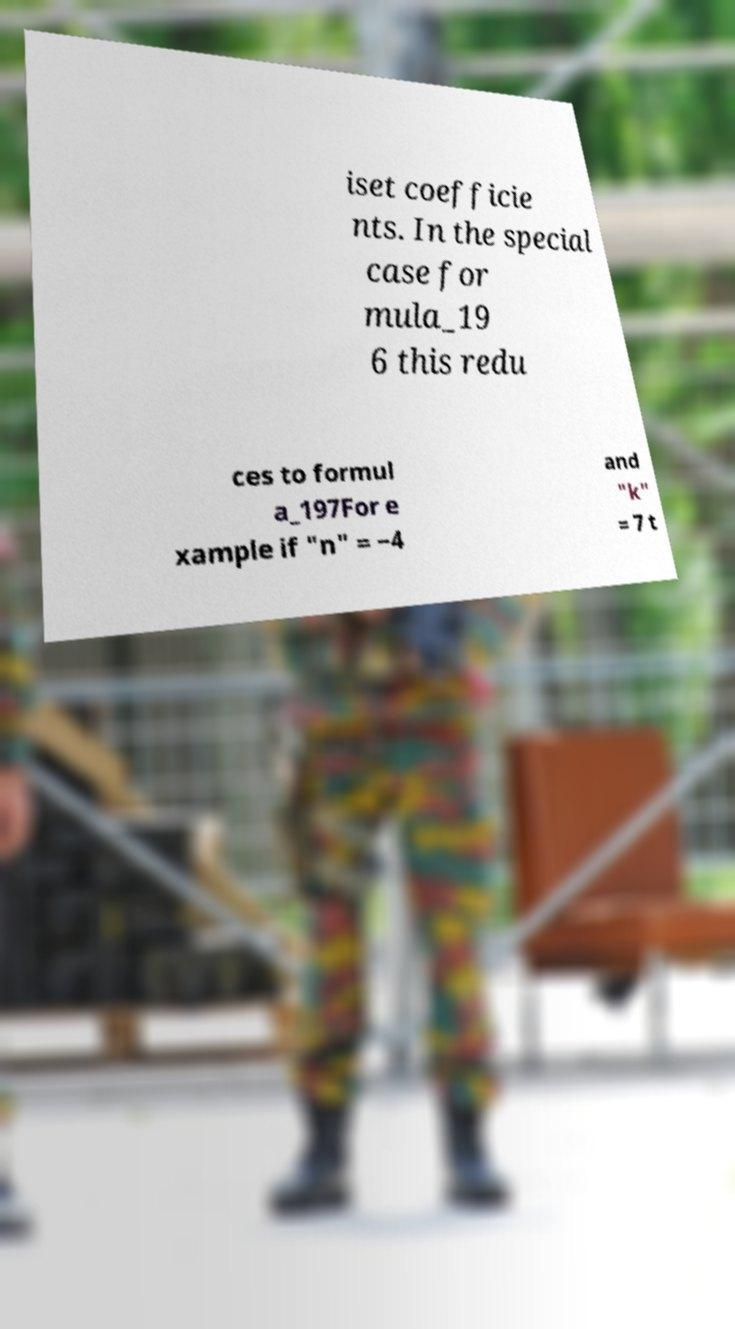Please read and relay the text visible in this image. What does it say? iset coefficie nts. In the special case for mula_19 6 this redu ces to formul a_197For e xample if "n" = −4 and "k" = 7 t 